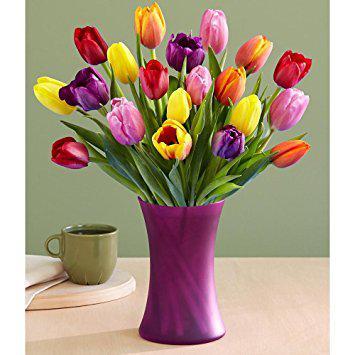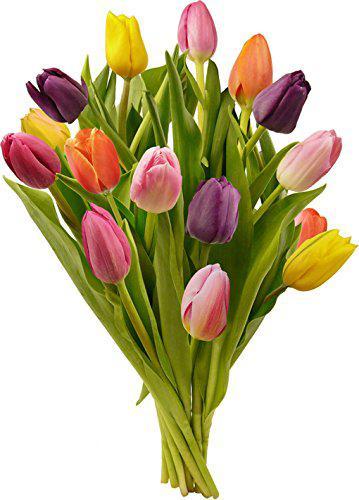The first image is the image on the left, the second image is the image on the right. Analyze the images presented: Is the assertion "Each of two vases of multicolored tulips is clear so that the green flower stems are visible, and contains at least three yellow flowers." valid? Answer yes or no. No. The first image is the image on the left, the second image is the image on the right. For the images displayed, is the sentence "Each image features multicolor tulips in a clear glass vase, and one of the vases has a rather spherical shape." factually correct? Answer yes or no. No. 